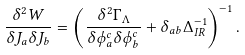Convert formula to latex. <formula><loc_0><loc_0><loc_500><loc_500>\frac { \delta ^ { 2 } W } { \delta J _ { a } \delta J _ { b } } = \left ( \frac { \delta ^ { 2 } \Gamma _ { \Lambda } } { \delta \phi ^ { c } _ { a } \delta \phi ^ { c } _ { b } } + \delta _ { a b } \Delta ^ { - 1 } _ { I R } \right ) ^ { - 1 } .</formula> 